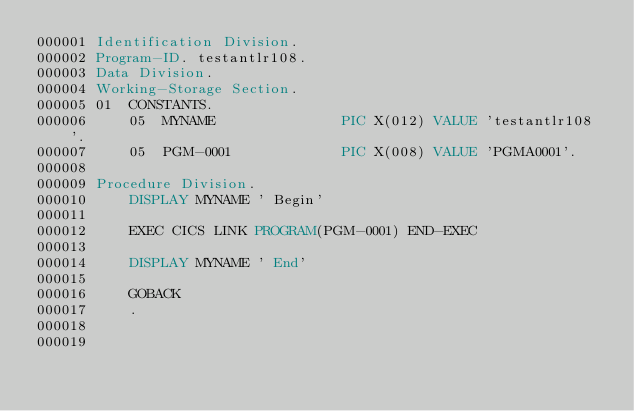<code> <loc_0><loc_0><loc_500><loc_500><_COBOL_>000001 Identification Division.
000002 Program-ID. testantlr108.
000003 Data Division.
000004 Working-Storage Section.
000005 01  CONSTANTS.
000006     05  MYNAME               PIC X(012) VALUE 'testantlr108'.
000007     05  PGM-0001             PIC X(008) VALUE 'PGMA0001'.
000008
000009 Procedure Division.
000010     DISPLAY MYNAME ' Begin'
000011     
000012     EXEC CICS LINK PROGRAM(PGM-0001) END-EXEC
000013
000014     DISPLAY MYNAME ' End'
000015     
000016     GOBACK
000017     .
000018
000019
</code> 